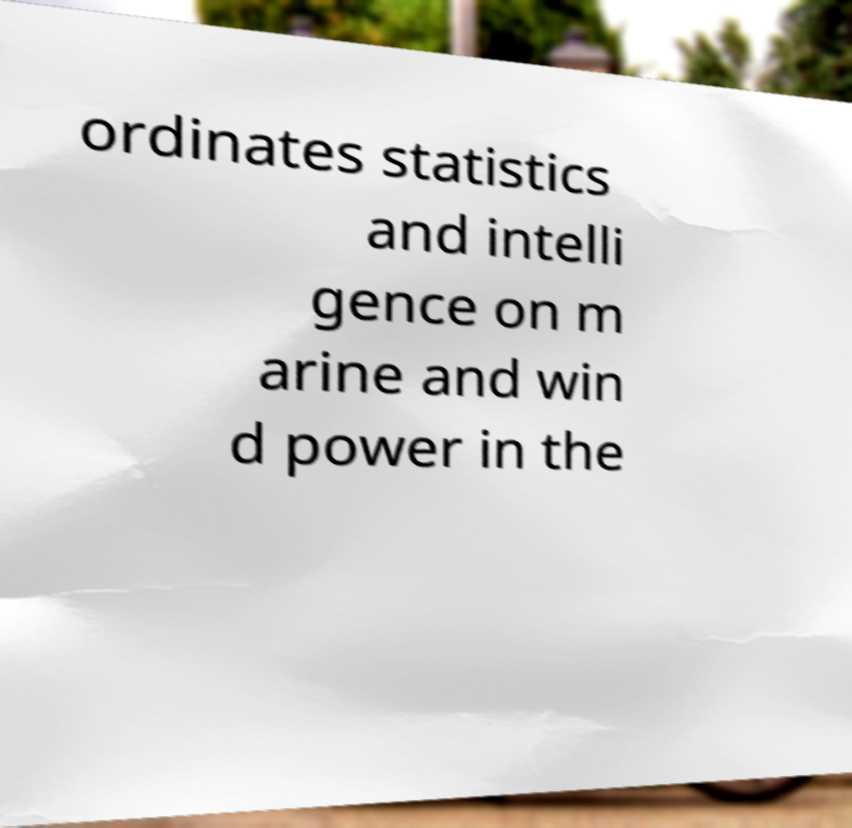Can you read and provide the text displayed in the image?This photo seems to have some interesting text. Can you extract and type it out for me? ordinates statistics and intelli gence on m arine and win d power in the 